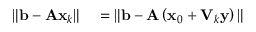Convert formula to latex. <formula><loc_0><loc_0><loc_500><loc_500>\begin{array} { r l } { \| b - A x _ { k } \| } & = \| b - A \left ( x _ { 0 } + V _ { k } y \right ) \| } \end{array}</formula> 